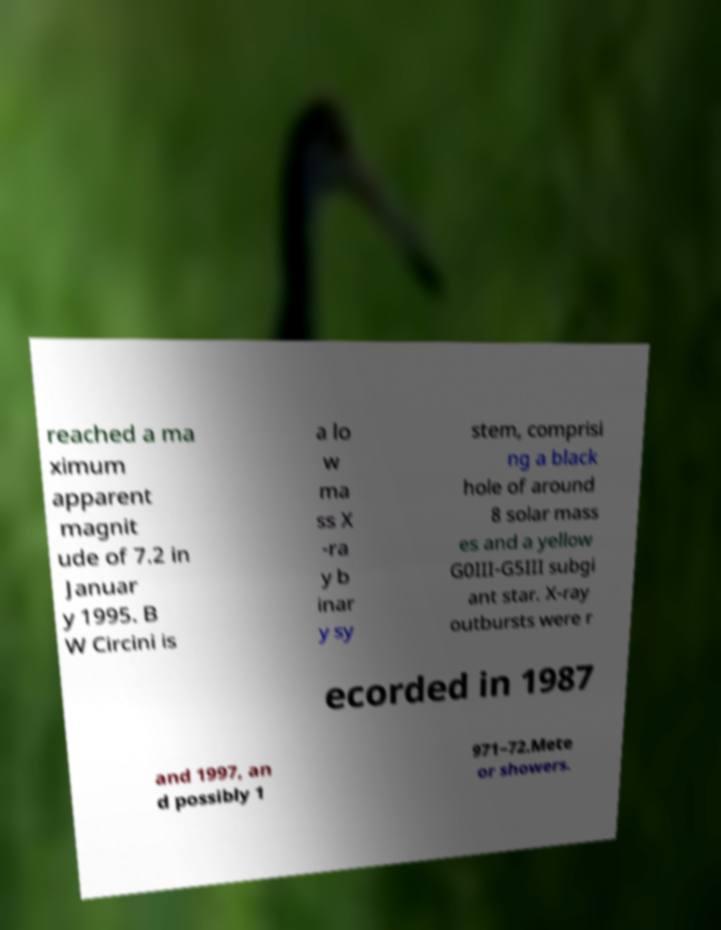Please identify and transcribe the text found in this image. reached a ma ximum apparent magnit ude of 7.2 in Januar y 1995. B W Circini is a lo w ma ss X -ra y b inar y sy stem, comprisi ng a black hole of around 8 solar mass es and a yellow G0III-G5III subgi ant star. X-ray outbursts were r ecorded in 1987 and 1997, an d possibly 1 971–72.Mete or showers. 